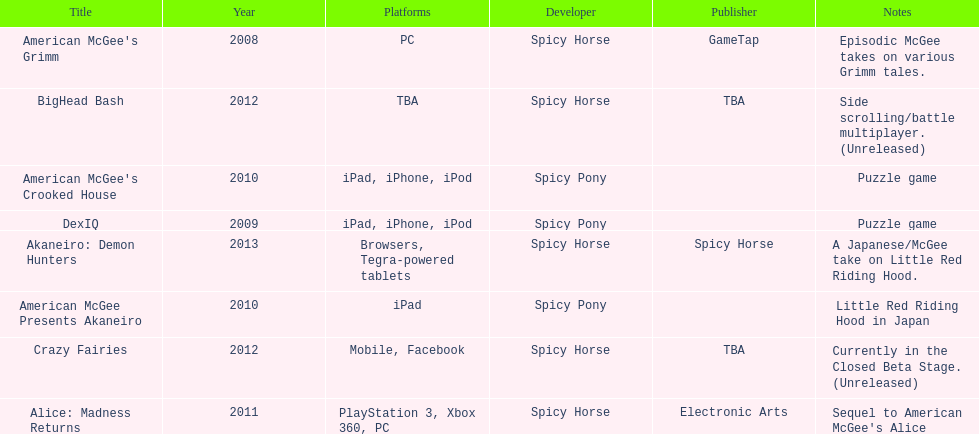According to the table, what is the last title that spicy horse produced? Akaneiro: Demon Hunters. 